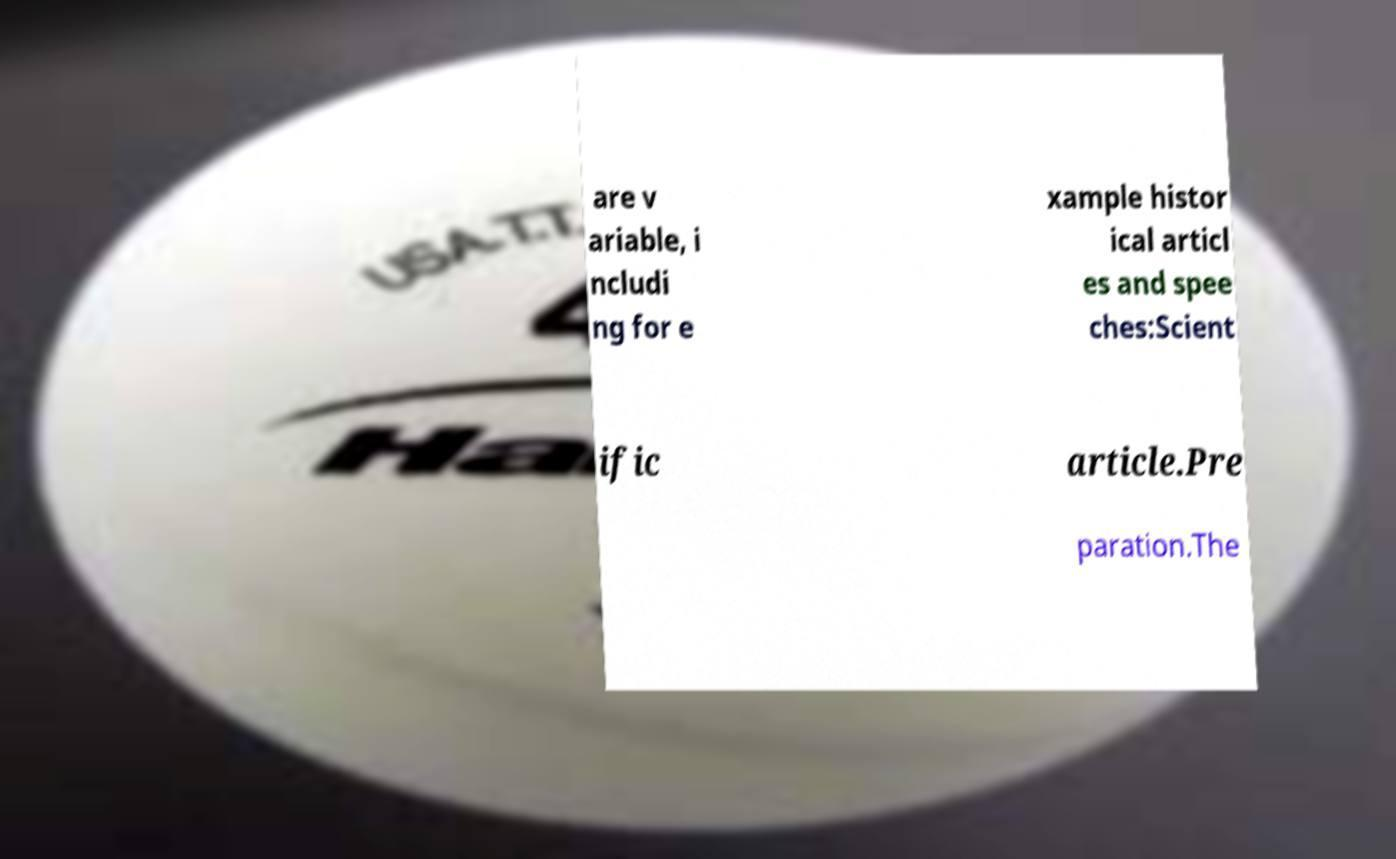For documentation purposes, I need the text within this image transcribed. Could you provide that? are v ariable, i ncludi ng for e xample histor ical articl es and spee ches:Scient ific article.Pre paration.The 